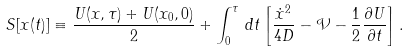Convert formula to latex. <formula><loc_0><loc_0><loc_500><loc_500>S [ x ( t ) ] \equiv \frac { U ( x , \tau ) + U ( x _ { 0 } , 0 ) } { 2 } + \int _ { 0 } ^ { \tau } \, d t \left [ \frac { \dot { x } ^ { 2 } } { 4 D } - \mathcal { V } - \frac { 1 } { 2 } \frac { \partial U } { \partial t } \right ] .</formula> 